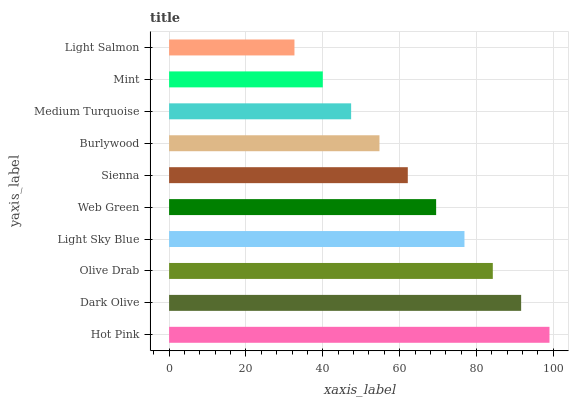Is Light Salmon the minimum?
Answer yes or no. Yes. Is Hot Pink the maximum?
Answer yes or no. Yes. Is Dark Olive the minimum?
Answer yes or no. No. Is Dark Olive the maximum?
Answer yes or no. No. Is Hot Pink greater than Dark Olive?
Answer yes or no. Yes. Is Dark Olive less than Hot Pink?
Answer yes or no. Yes. Is Dark Olive greater than Hot Pink?
Answer yes or no. No. Is Hot Pink less than Dark Olive?
Answer yes or no. No. Is Web Green the high median?
Answer yes or no. Yes. Is Sienna the low median?
Answer yes or no. Yes. Is Light Sky Blue the high median?
Answer yes or no. No. Is Web Green the low median?
Answer yes or no. No. 